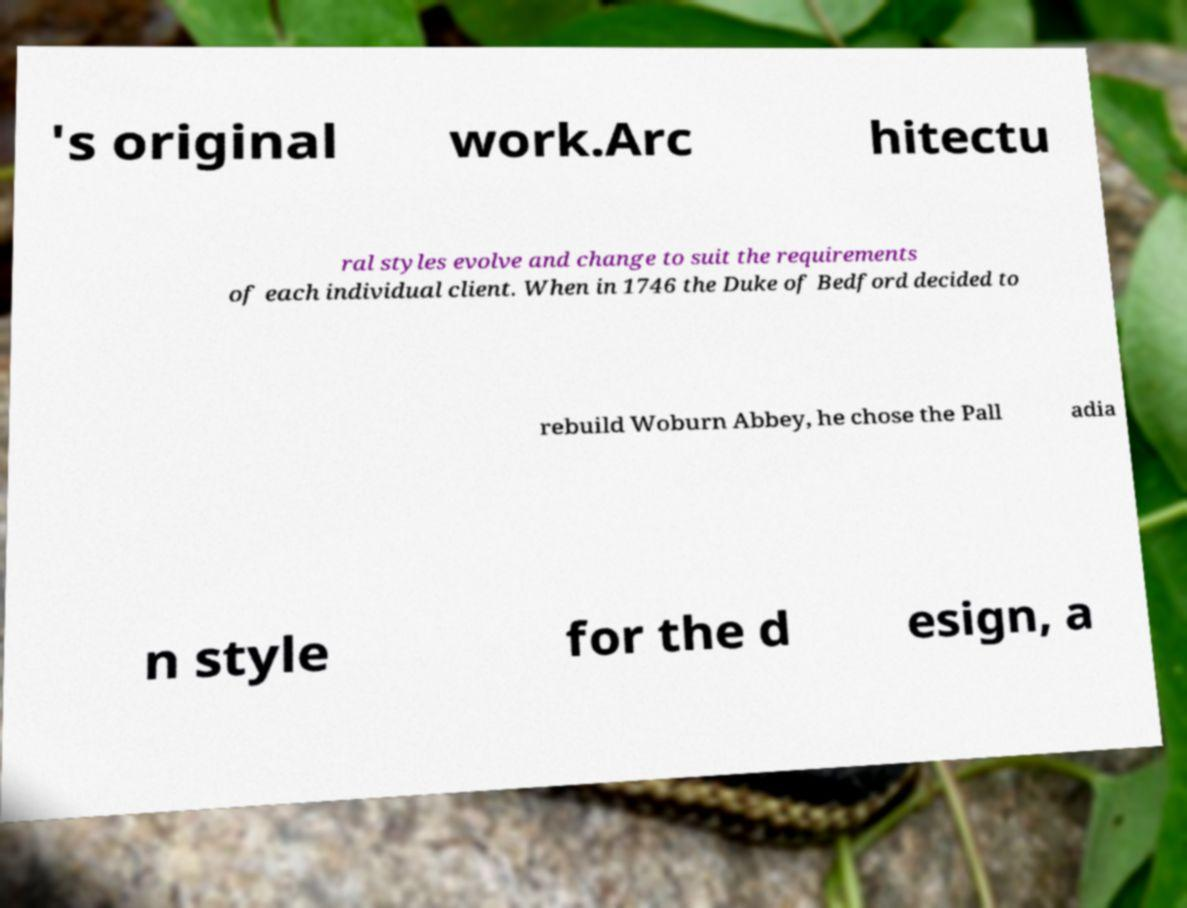Could you assist in decoding the text presented in this image and type it out clearly? 's original work.Arc hitectu ral styles evolve and change to suit the requirements of each individual client. When in 1746 the Duke of Bedford decided to rebuild Woburn Abbey, he chose the Pall adia n style for the d esign, a 